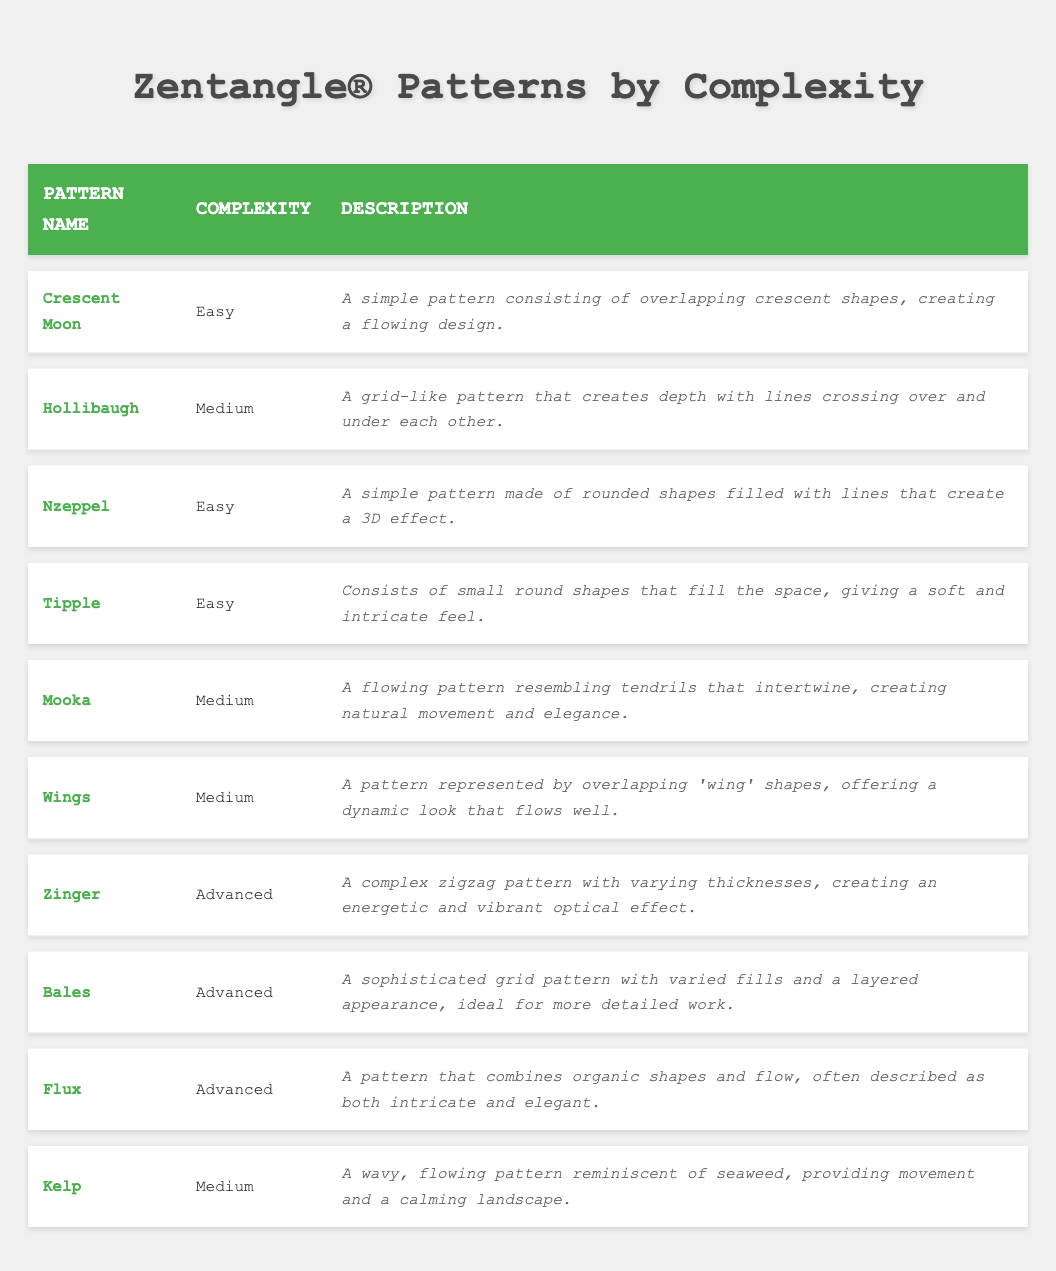What's the easiest pattern listed in the table? The table lists patterns along with their complexity. Scanning through the complexity column, the patterns "Crescent Moon," "Nzeppel," and "Tipple" are marked as "Easy."
Answer: Crescent Moon How many patterns are classified as medium complexity? By reviewing the complexity column, the patterns "Hollibaugh," "Mooka," "Wings," and "Kelp" are categorized as medium. Counting these, there are four medium patterns listed.
Answer: 4 Is "Zinger" considered an advanced pattern? Looking at the complexity column, "Zinger" is indeed marked as "Advanced," confirming that it falls into this category.
Answer: Yes Which pattern has a description related to flowing design? The term "flowing design" appears in the description for both "Crescent Moon" and "Mooka." Therefore, I need to check the pattern names directly associated with the description in the table.
Answer: Crescent Moon, Mooka What is the total number of easy and advanced patterns combined? The easy patterns are "Crescent Moon," "Nzeppel," and "Tipple," totaling 3, while the advanced patterns "Zinger," "Bales," and "Flux" also total to 3. Adding these together gives 3 + 3 = 6.
Answer: 6 Which pattern describes a 3D effect? The pattern "Nzeppel" has a description mentioning a 3D effect. I can confirm this by looking at its respective description in the table.
Answer: Nzeppel How many patterns involve overlapping shapes? The patterns "Crescent Moon" (overlapping crescent shapes) and "Wings" (overlapping 'wing' shapes) describe the use of overlapping shapes. This counts up to 2 patterns.
Answer: 2 Are there more easy patterns or advanced patterns in the table? The easy patterns listed are "Crescent Moon," "Nzeppel," and "Tipple" (3 total), while the advanced patterns are "Zinger," "Bales," and "Flux" (also 3 total). Since both counts are equal, there are not more of one than the other.
Answer: Neither 